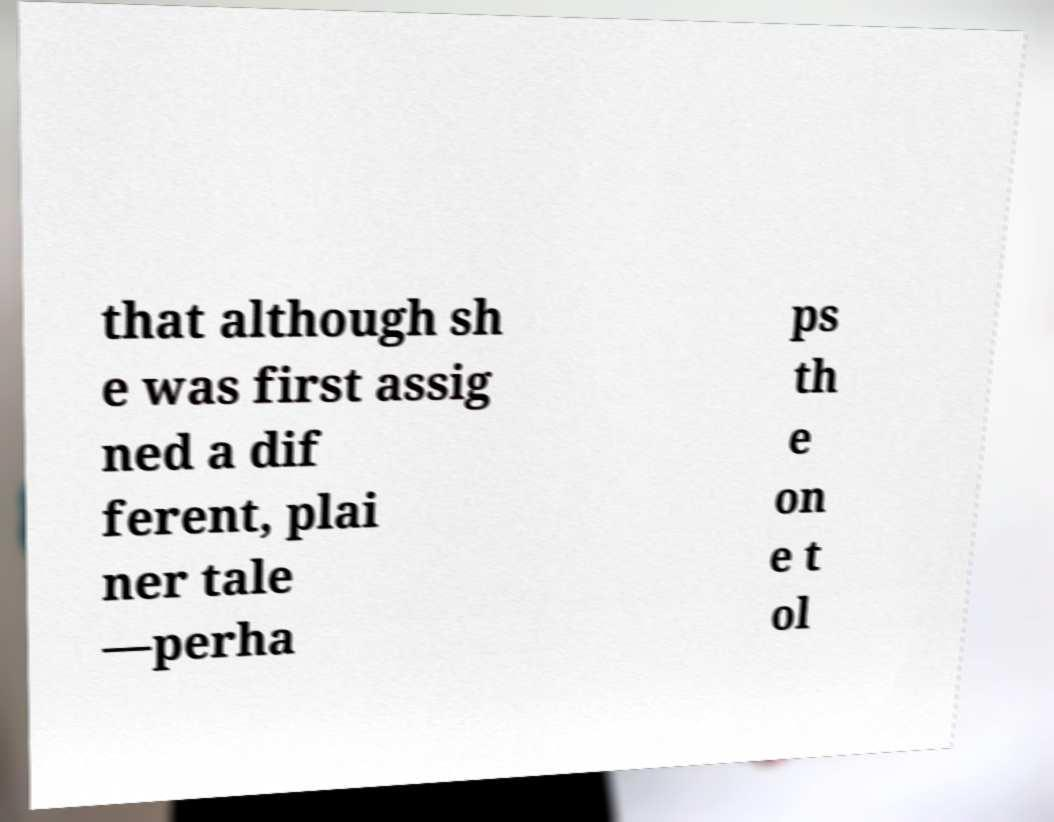I need the written content from this picture converted into text. Can you do that? that although sh e was first assig ned a dif ferent, plai ner tale —perha ps th e on e t ol 